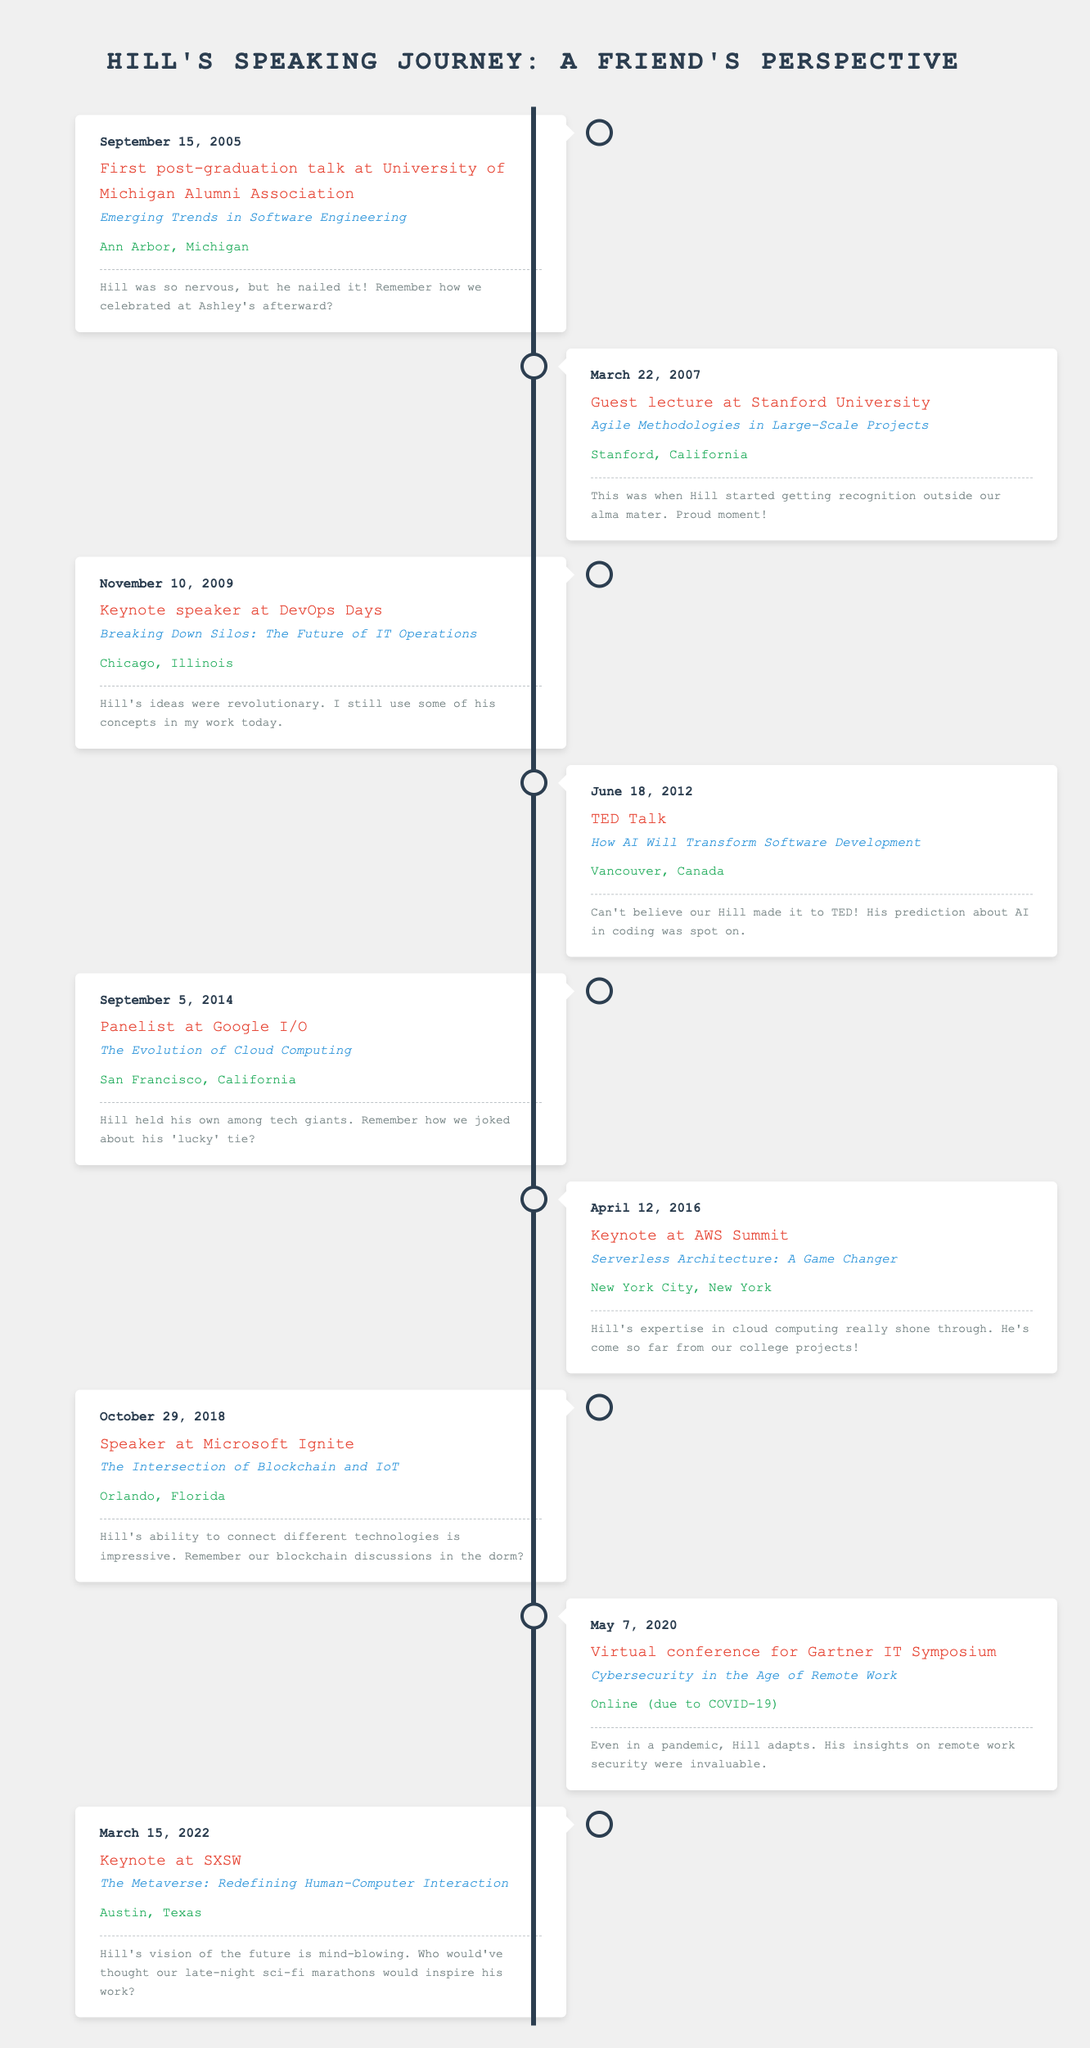What was Hill's first speaking engagement after graduation? The first speaking engagement after graduation can be found in the first row of the table, which states that Hill gave a talk at the University of Michigan Alumni Association on September 15, 2005.
Answer: University of Michigan Alumni Association How many times did Hill serve as a keynote speaker? By reviewing the table, we note the events labeled as "Keynote" in the content: 1) DevOps Days, 2) TED Talk, 3) AWS Summit, and 4) SXSW. Thus, the total is four keynote presentations.
Answer: Four Did Hill speak at any events in 2020? The table indicates Hill participated in a virtual conference for the Gartner IT Symposium on May 7, 2020. Therefore, the answer is yes.
Answer: Yes Which event took place in 2012? By looking through the dates in the table, the event labeled as TED Talk on June 18, 2012, can be identified for this year.
Answer: TED Talk Identify the location of Hill's keynote at AWS Summit. The AWS Summit keynote is listed in the table, specifically mentioning New York City, New York, under the location.
Answer: New York City, New York What is the average time gap between Hill's speaking engagements from 2005 to 2022? First, we identify the dates of engagement: 2005, 2007, 2009, 2012, 2014, 2016, 2018, 2020, and 2022. Calculating the time interval yields 17 years (2005 to 2022) and there are 8 engagements. Dividing the total gap (17 years) by (8 - 1) gives approximately 2.43 years.
Answer: 2.43 years Was Hill a panelist at Google I/O? Referring to the table, it cites the entry for September 5, 2014, as Hill being a panelist at Google I/O. Thus, the answer is yes.
Answer: Yes What was the topic discussed during Hill's speech at Microsoft Ignite? The table clearly states that Hill spoke on "The Intersection of Blockchain and IoT" during the Microsoft Ignite event, which took place on October 29, 2018.
Answer: The Intersection of Blockchain and IoT How many events took place between 2010 and 2015? Examining the events listed between the years 2010 and 2015, we find: DevOps Days (2009), TED Talk (2012), Google I/O (2014), and AWS Summit (2016), which indicates a total of 3 events (2010, 2011, 2012, 2014, 2015 include a total of 3 events).
Answer: Three 